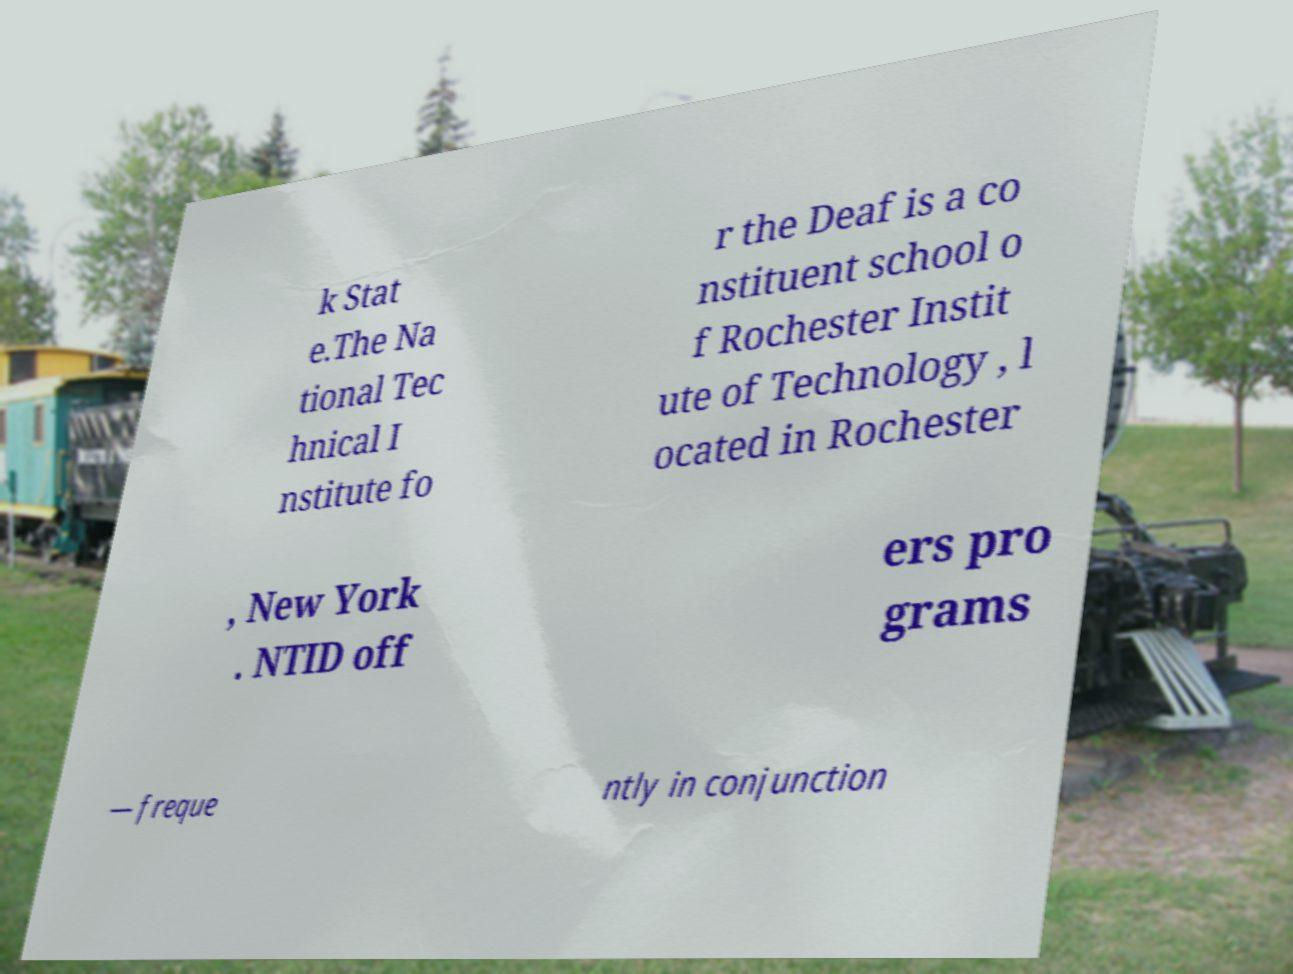Please read and relay the text visible in this image. What does it say? k Stat e.The Na tional Tec hnical I nstitute fo r the Deaf is a co nstituent school o f Rochester Instit ute of Technology , l ocated in Rochester , New York . NTID off ers pro grams — freque ntly in conjunction 